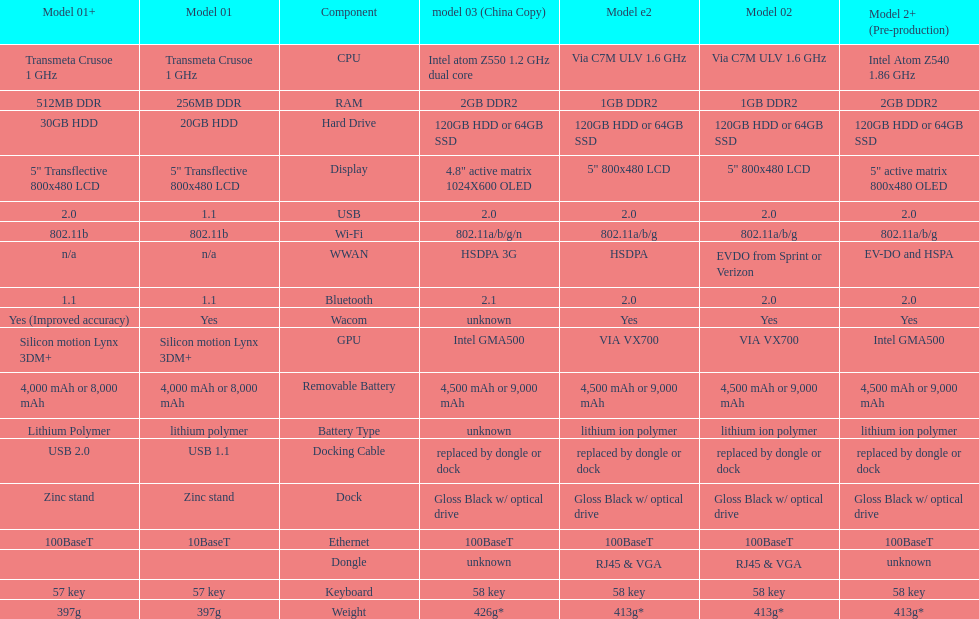What is the weight difference between model 3 and model 1? 29g. 